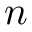<formula> <loc_0><loc_0><loc_500><loc_500>n</formula> 